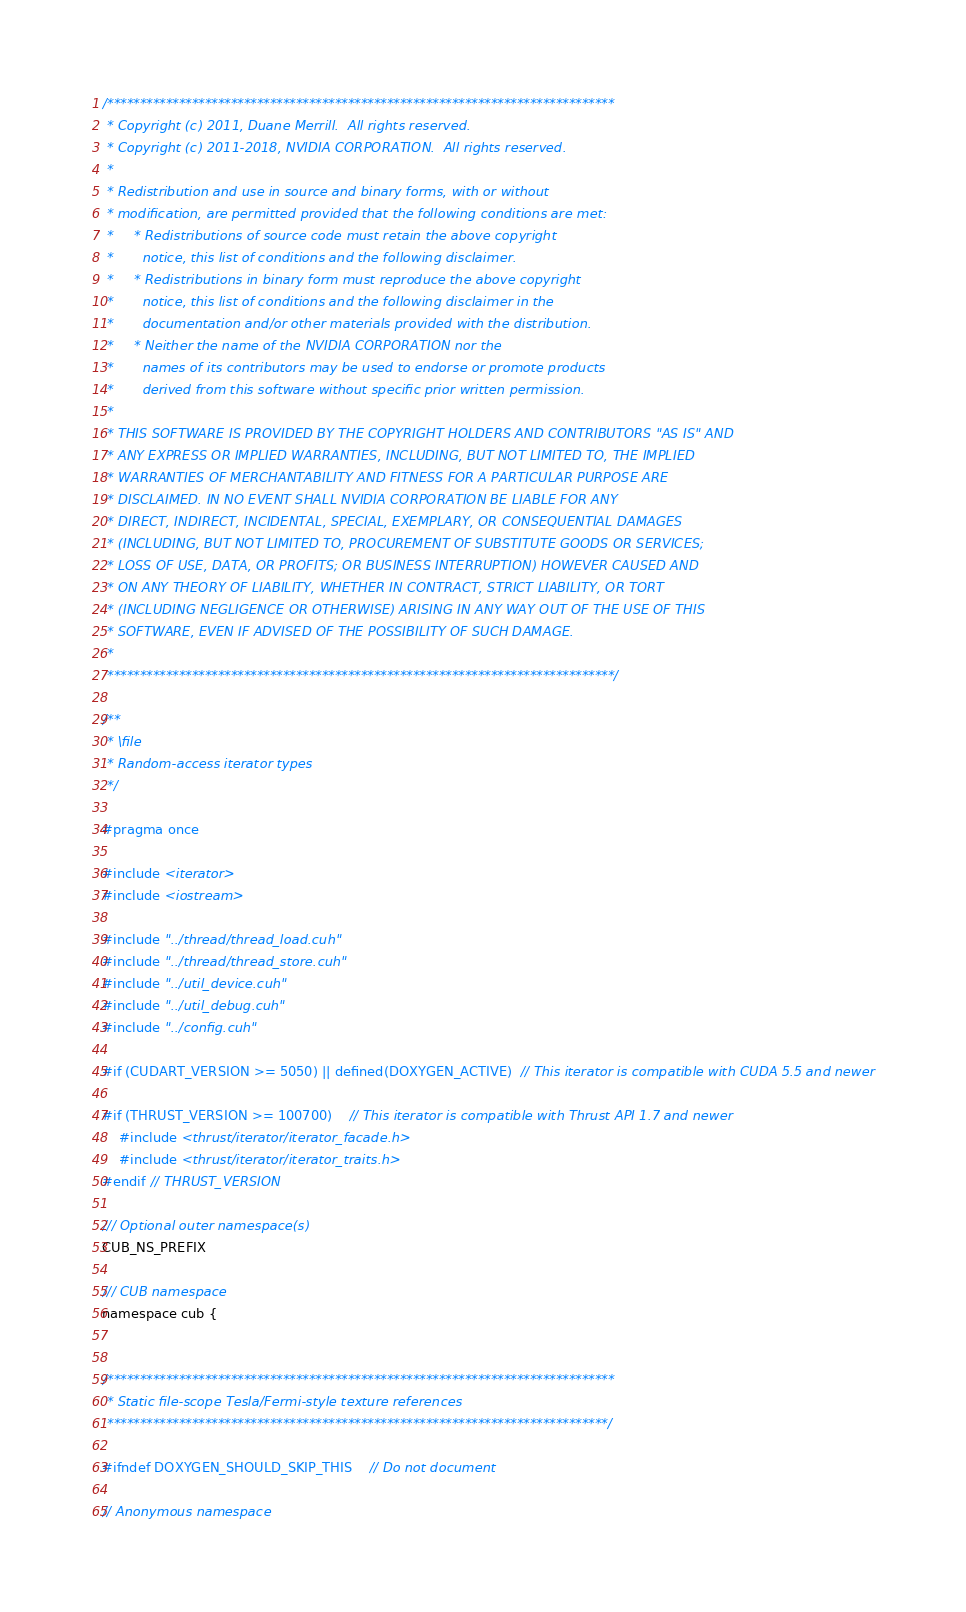Convert code to text. <code><loc_0><loc_0><loc_500><loc_500><_Cuda_>/******************************************************************************
 * Copyright (c) 2011, Duane Merrill.  All rights reserved.
 * Copyright (c) 2011-2018, NVIDIA CORPORATION.  All rights reserved.
 *
 * Redistribution and use in source and binary forms, with or without
 * modification, are permitted provided that the following conditions are met:
 *     * Redistributions of source code must retain the above copyright
 *       notice, this list of conditions and the following disclaimer.
 *     * Redistributions in binary form must reproduce the above copyright
 *       notice, this list of conditions and the following disclaimer in the
 *       documentation and/or other materials provided with the distribution.
 *     * Neither the name of the NVIDIA CORPORATION nor the
 *       names of its contributors may be used to endorse or promote products
 *       derived from this software without specific prior written permission.
 *
 * THIS SOFTWARE IS PROVIDED BY THE COPYRIGHT HOLDERS AND CONTRIBUTORS "AS IS" AND
 * ANY EXPRESS OR IMPLIED WARRANTIES, INCLUDING, BUT NOT LIMITED TO, THE IMPLIED
 * WARRANTIES OF MERCHANTABILITY AND FITNESS FOR A PARTICULAR PURPOSE ARE
 * DISCLAIMED. IN NO EVENT SHALL NVIDIA CORPORATION BE LIABLE FOR ANY
 * DIRECT, INDIRECT, INCIDENTAL, SPECIAL, EXEMPLARY, OR CONSEQUENTIAL DAMAGES
 * (INCLUDING, BUT NOT LIMITED TO, PROCUREMENT OF SUBSTITUTE GOODS OR SERVICES;
 * LOSS OF USE, DATA, OR PROFITS; OR BUSINESS INTERRUPTION) HOWEVER CAUSED AND
 * ON ANY THEORY OF LIABILITY, WHETHER IN CONTRACT, STRICT LIABILITY, OR TORT
 * (INCLUDING NEGLIGENCE OR OTHERWISE) ARISING IN ANY WAY OUT OF THE USE OF THIS
 * SOFTWARE, EVEN IF ADVISED OF THE POSSIBILITY OF SUCH DAMAGE.
 *
 ******************************************************************************/

/**
 * \file
 * Random-access iterator types
 */

#pragma once

#include <iterator>
#include <iostream>

#include "../thread/thread_load.cuh"
#include "../thread/thread_store.cuh"
#include "../util_device.cuh"
#include "../util_debug.cuh"
#include "../config.cuh"

#if (CUDART_VERSION >= 5050) || defined(DOXYGEN_ACTIVE)  // This iterator is compatible with CUDA 5.5 and newer

#if (THRUST_VERSION >= 100700)    // This iterator is compatible with Thrust API 1.7 and newer
    #include <thrust/iterator/iterator_facade.h>
    #include <thrust/iterator/iterator_traits.h>
#endif // THRUST_VERSION

/// Optional outer namespace(s)
CUB_NS_PREFIX

/// CUB namespace
namespace cub {


/******************************************************************************
 * Static file-scope Tesla/Fermi-style texture references
 *****************************************************************************/

#ifndef DOXYGEN_SHOULD_SKIP_THIS    // Do not document

// Anonymous namespace</code> 